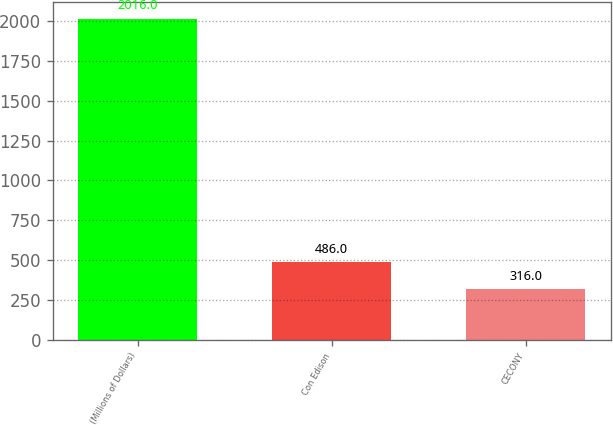<chart> <loc_0><loc_0><loc_500><loc_500><bar_chart><fcel>(Millions of Dollars)<fcel>Con Edison<fcel>CECONY<nl><fcel>2016<fcel>486<fcel>316<nl></chart> 